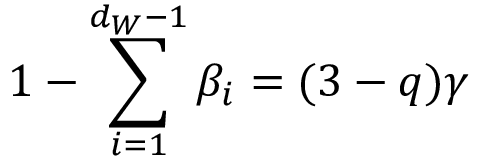Convert formula to latex. <formula><loc_0><loc_0><loc_500><loc_500>1 - \sum _ { i = 1 } ^ { d _ { W } - 1 } \beta _ { i } = ( 3 - q ) \gamma</formula> 